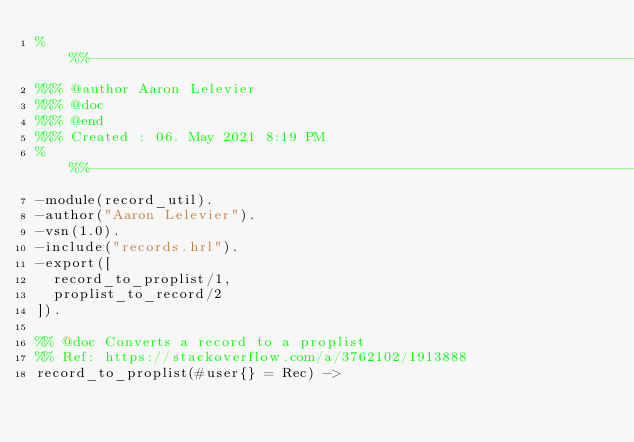Convert code to text. <code><loc_0><loc_0><loc_500><loc_500><_Erlang_>%%%-------------------------------------------------------------------
%%% @author Aaron Lelevier
%%% @doc
%%% @end
%%% Created : 06. May 2021 8:19 PM
%%%-------------------------------------------------------------------
-module(record_util).
-author("Aaron Lelevier").
-vsn(1.0).
-include("records.hrl").
-export([
  record_to_proplist/1,
  proplist_to_record/2
]).

%% @doc Converts a record to a proplist
%% Ref: https://stackoverflow.com/a/3762102/1913888
record_to_proplist(#user{} = Rec) -></code> 